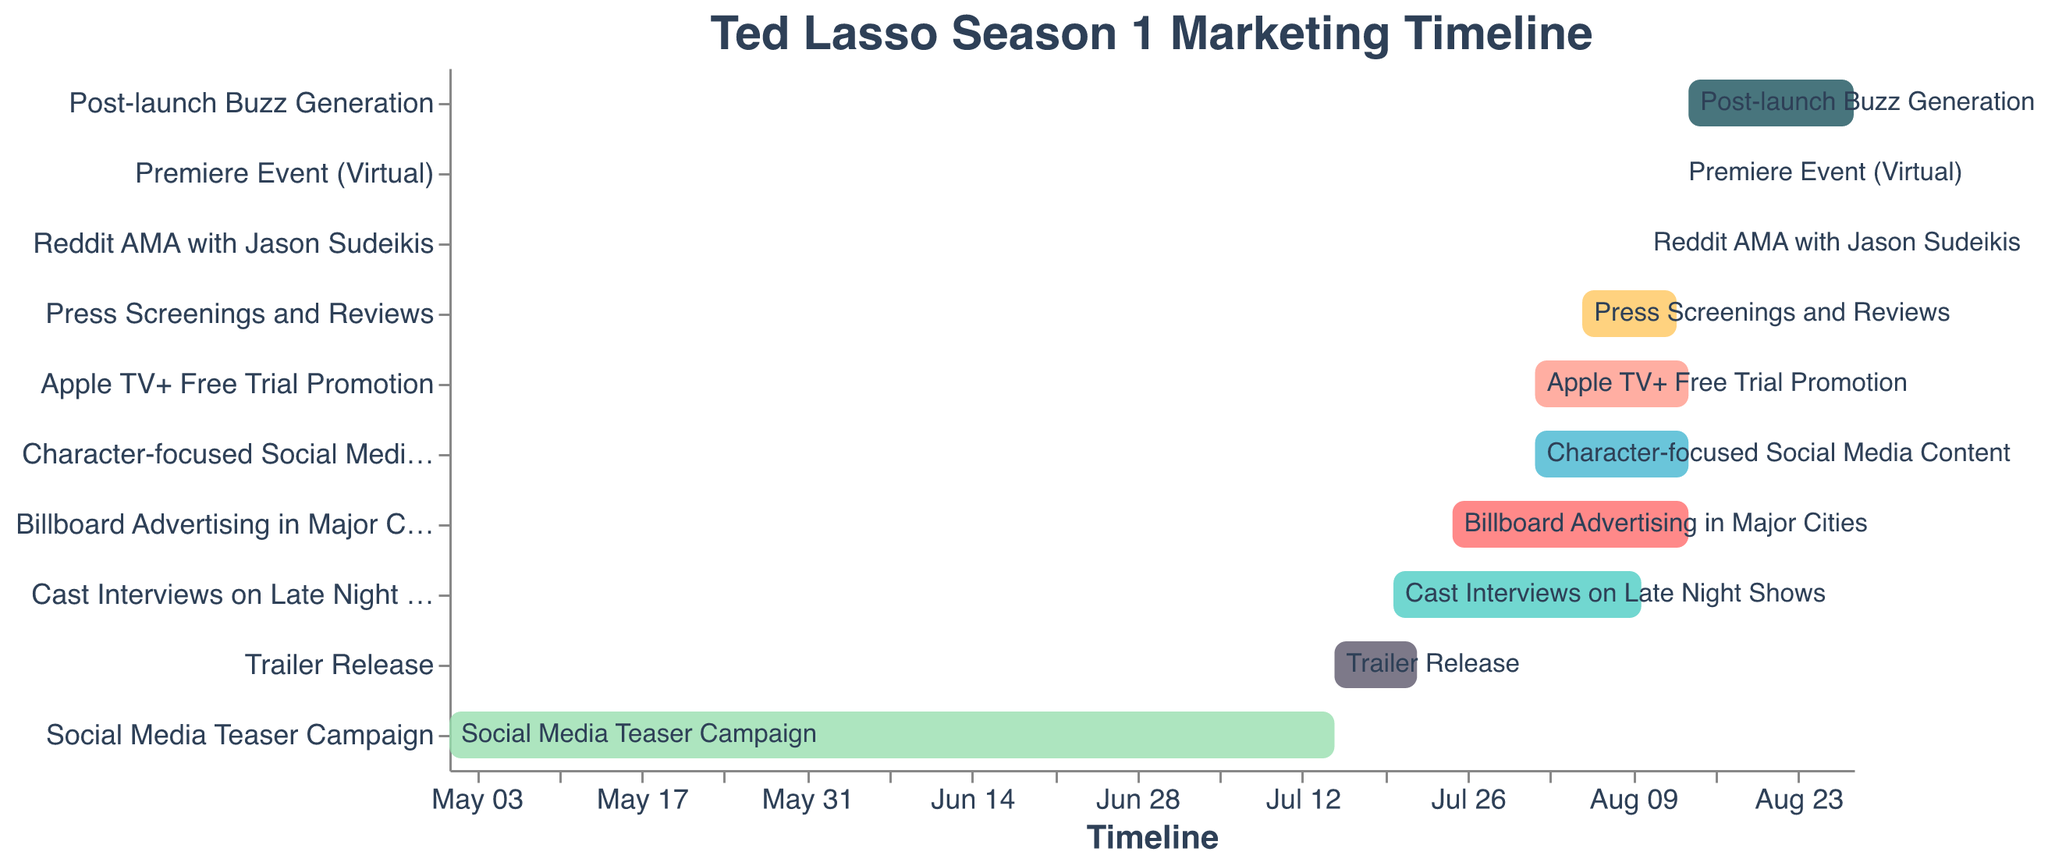What is the duration of the Social Media Teaser Campaign? The Social Media Teaser Campaign starts on May 1, 2020, and ends on July 15, 2020. To find the duration, count the days between these dates, which equals 76 days.
Answer: 76 days Which promotional activity starts the earliest, and when does it begin? The Social Media Teaser Campaign starts the earliest on May 1, 2020.
Answer: May 1, 2020 How many promotional activities overlap on August 10, 2020? The activities overlapping on August 10, 2020, are Cast Interviews on Late Night Shows, Billboard Advertising in Major Cities, Apple TV+ Free Trial Promotion, Reddit AMA with Jason Sudeikis, Character-focused Social Media Content, and Press Screenings and Reviews. Count these to get 6 activities.
Answer: 6 What activity has the shortest duration, and how long does it last? The Reddit AMA with Jason Sudeikis and the Premiere Event (Virtual) both have the shortest duration, each lasting only one day (August 10, 2020, and August 13, 2020, respectively).
Answer: Reddit AMA with Jason Sudeikis and Premiere Event (Virtual), 1 day each What is the total duration for the Press Screenings and Reviews activity? The Press Screenings and Reviews activity starts on August 5, 2020, and ends on August 13, 2020. Count the days between these dates to get a duration of 9 days.
Answer: 9 days Which promotional activity ends the latest, and what is its end date? The Post-launch Buzz Generation ends the latest on August 28, 2020.
Answer: August 28, 2020 Are there more activities starting in July or August? Activities starting in July are Trailer Release, Cast Interviews on Late Night Shows, and Billboard Advertising in Major Cities (3 activities). Activities starting in August are Apple TV+ Free Trial Promotion, Press Screenings and Reviews, Character-focused Social Media Content, and Reddit AMA with Jason Sudeikis (4 activities). Compare the counts to see that more activities start in August.
Answer: August Which promotional activities run concurrently with the Billboard Advertising in Major Cities between July 25, 2020, and August 14, 2020? The activities concurrent with Billboard Advertising in Major Cities are Cast Interviews on Late Night Shows, Apple TV+ Free Trial Promotion, Press Screenings and Reviews, and Character-focused Social Media Content. Cross-reference the dates to verify overlap.
Answer: Cast Interviews on Late Night Shows, Apple TV+ Free Trial Promotion, Press Screenings and Reviews, Character-focused Social Media Content 